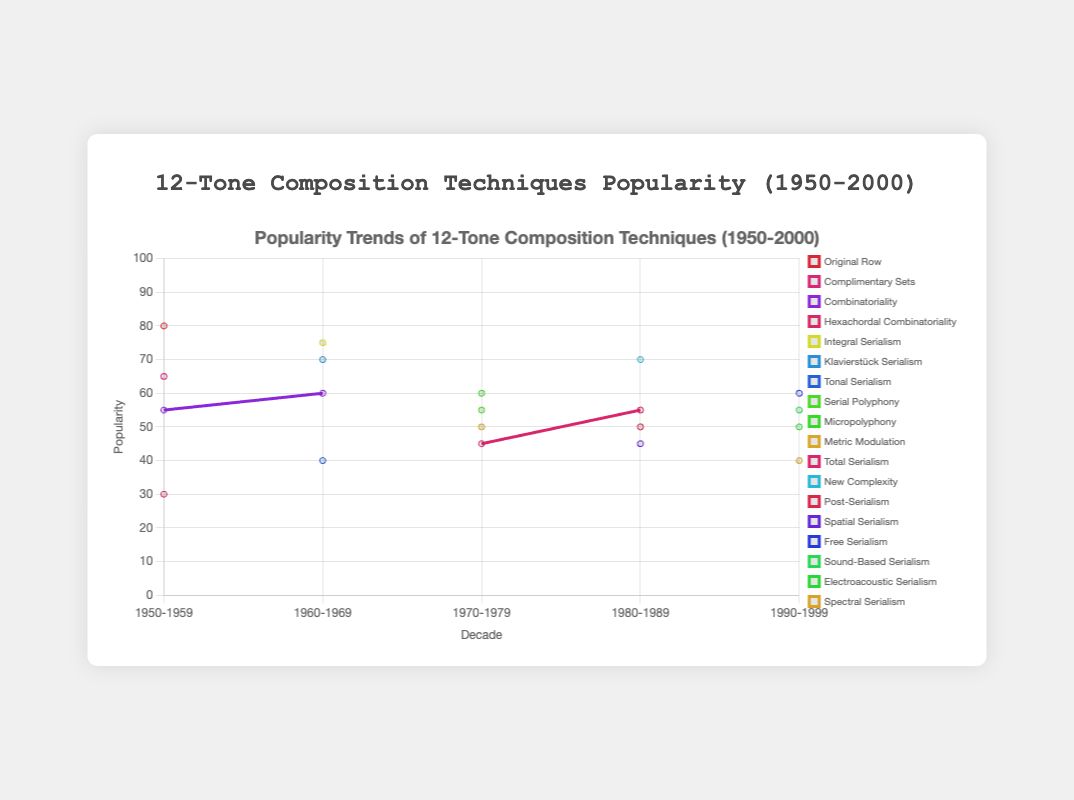Which decade saw the highest popularity for Arnold Schoenberg's "Original Row" technique? Identify the point in the dataset where Arnold Schoenberg's "Original Row" has the highest value on the y-axis.
Answer: 1950-1959 Which decade did Pierre Boulez's "Integral Serialism" have its peak popularity according to the figure? Look for the decade where Pierre Boulez's "Integral Serialism" has the highest point on the y-axis.
Answer: 1960-1969 Comparing Milton Babbitt’s technique of "Combinatoriality," was it more popular in the 1950s or the 1960s? Check the popularity values for "Combinatoriality" in both the 1950s and 1960s decades, then compare these values. Milton Babbitt’s "Combinatoriality" had a popularity of 55 in the 1950s and 60 in the 1960s. Thus it was more popular in the 1960s.
Answer: 1960s Among the given techniques, which one saw a continuous rise in popularity every successive decade? Observe the trends in the popularity values for each technique across all decades. Notice that none of the techniques show a continuous rise every decade; popularity generally fluctuates.
Answer: None Taking both the 1970s and the 1980s into account, what was the combined popularity value of "Total Serialism"? Sum the popularity values of "Total Serialism" from 1970-1979 and 1980-1989. The popularity values are 45 and 55, respectively. Therefore, the combined value is 45 + 55 = 100.
Answer: 100 Which technique had the lowest popularity in the 1990s? Identify the technique with the minimum y-axis value in the 1990-1999 decade section. The lowest value is for Kaija Saariaho's "Spectral Serialism" with a popularity of 40.
Answer: Spectral Serialism How much did the popularity of Klavierstück Serialism change from its peak in the 1960s to the next observed decade? The popularity of Klavierstück Serialism in the 1960s was 70. It does not appear in the 1970s or later decades, implying a drop to 0. Thus, the change is 70 - 0 = 70.
Answer: 70 Which composer had the maximum popularity score in any decade, and what was the score? Find the highest point on the y-axis across all the decades. Arnold Schoenberg's "Original Row" in the 1950-1959 decade had the maximum popularity score of 80.
Answer: Arnold Schoenberg, 80 